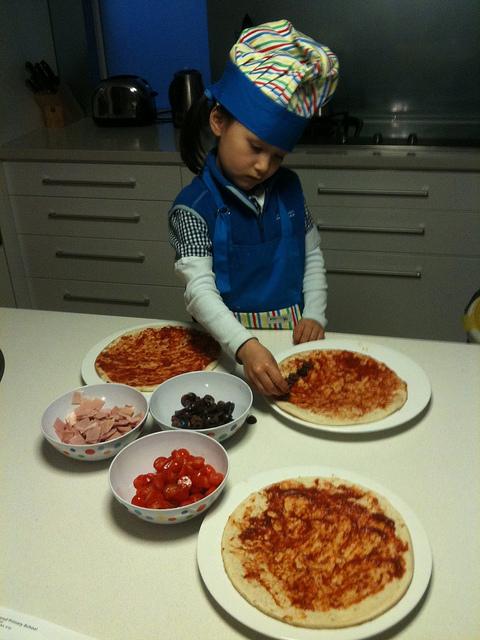Will this child own a pizzeria?
Write a very short answer. Yes. Is this a restaurant?
Answer briefly. No. What type of hat is the child wearing?
Keep it brief. Chef. 